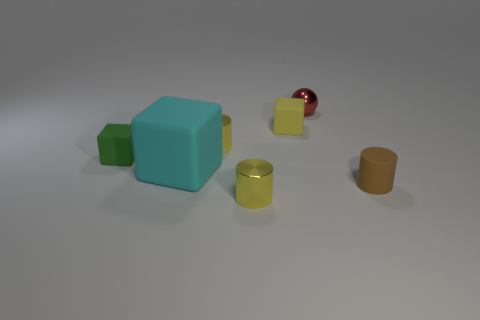Subtract all small yellow cylinders. How many cylinders are left? 1 Subtract all cylinders. How many objects are left? 4 Add 1 small shiny cylinders. How many objects exist? 8 Subtract all brown cylinders. How many cylinders are left? 2 Add 2 cyan things. How many cyan things exist? 3 Subtract 2 yellow cylinders. How many objects are left? 5 Subtract 1 balls. How many balls are left? 0 Subtract all brown spheres. Subtract all red cylinders. How many spheres are left? 1 Subtract all blue cubes. How many purple balls are left? 0 Subtract all yellow objects. Subtract all rubber objects. How many objects are left? 0 